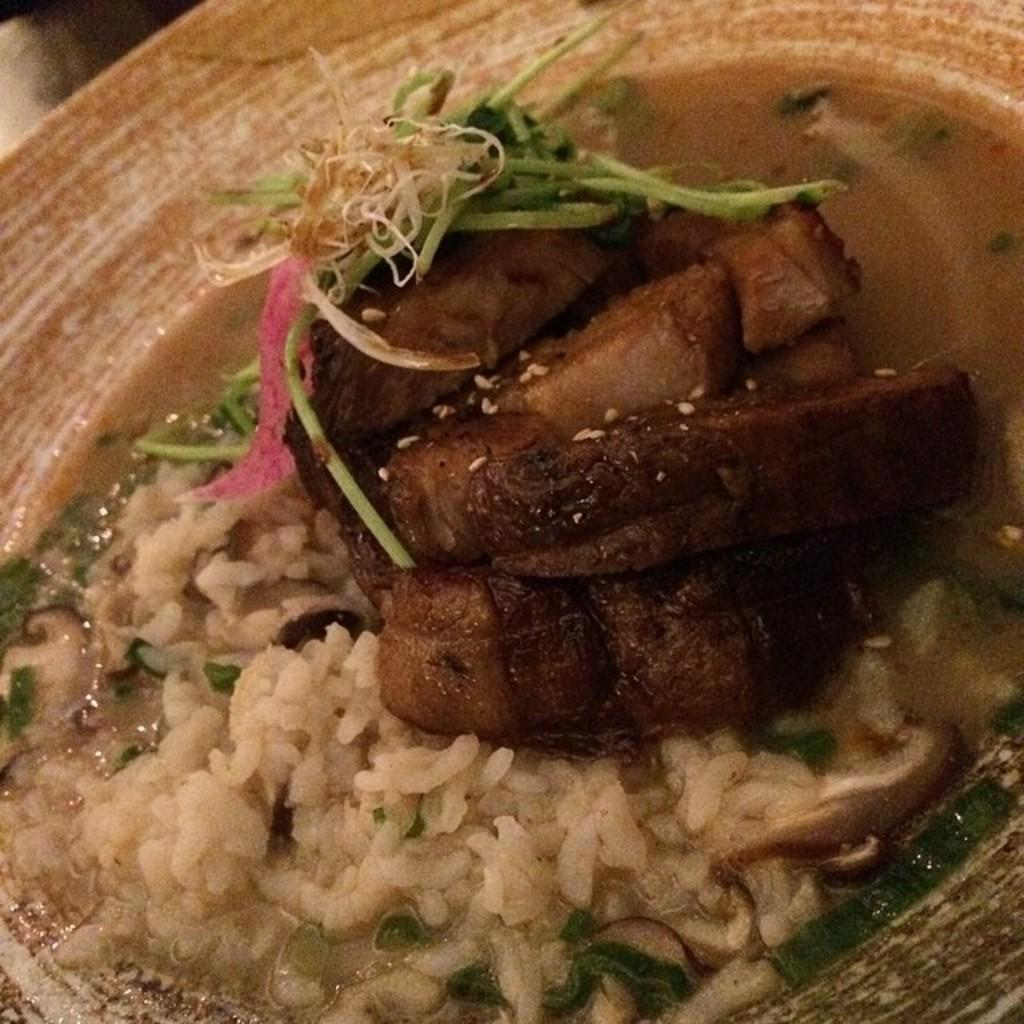What type of food is on the plate in the image? There are fried fishes and rice on the plate. Are there any other food items on the plate? Yes, there are other food items on the plate. What is the location of the plate in the image? The plate is kept on a table. Is there any sauce on the plate? Yes, there is sauce (possibly a transcription error, should be "sauce") on the plate. Can you see any gates in the image? No, there are no gates present in the image. Are there any icicles hanging from the plate in the image? No, there are no icicles present in the image. 